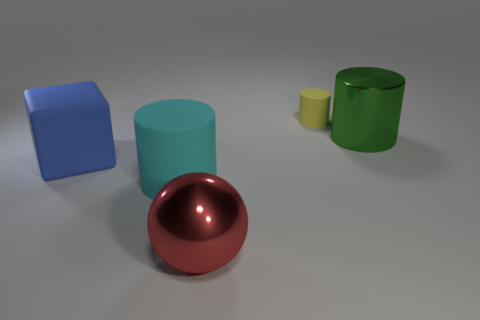Is the red metallic object the same size as the yellow matte thing?
Provide a succinct answer. No. The metal object that is the same shape as the tiny yellow rubber thing is what size?
Make the answer very short. Large. Are there any other things that are the same size as the red metal object?
Your response must be concise. Yes. There is a thing behind the large thing behind the blue rubber cube; what is its material?
Your answer should be very brief. Rubber. Is the shape of the big blue rubber thing the same as the yellow thing?
Your answer should be compact. No. How many large things are both left of the cyan cylinder and behind the blue matte object?
Your answer should be compact. 0. Is the number of large cyan objects that are in front of the big red sphere the same as the number of big matte cubes that are behind the yellow object?
Offer a very short reply. Yes. There is a rubber cylinder to the left of the small yellow matte object; is its size the same as the shiny object in front of the big blue matte block?
Provide a short and direct response. Yes. What material is the big thing that is both on the right side of the blue block and to the left of the red thing?
Your response must be concise. Rubber. Is the number of metallic objects less than the number of big green metallic cylinders?
Your response must be concise. No. 